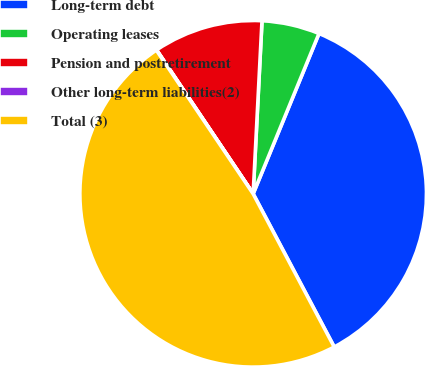<chart> <loc_0><loc_0><loc_500><loc_500><pie_chart><fcel>Long-term debt<fcel>Operating leases<fcel>Pension and postretirement<fcel>Other long-term liabilities(2)<fcel>Total (3)<nl><fcel>36.05%<fcel>5.39%<fcel>10.22%<fcel>0.03%<fcel>48.31%<nl></chart> 